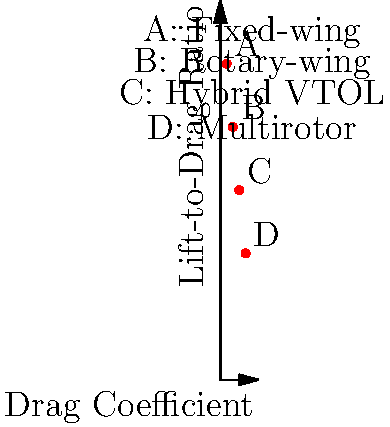Based on the aerodynamic performance chart of different military drone designs, which type of drone is likely to have the best range and endurance for long-duration surveillance missions? To determine which drone design is best suited for long-duration surveillance missions, we need to analyze the aerodynamic performance chart:

1. The x-axis represents the drag coefficient, where a lower value indicates less air resistance.
2. The y-axis shows the lift-to-drag ratio, where a higher value indicates better aerodynamic efficiency.

Let's examine each drone type:

A (Fixed-wing): 
- Lowest drag coefficient (≈0.2)
- Highest lift-to-drag ratio (≈10)

B (Rotary-wing):
- Second-lowest drag coefficient (≈0.4)
- Second-highest lift-to-drag ratio (≈8)

C (Hybrid VTOL):
- Second-highest drag coefficient (≈0.6)
- Third-highest lift-to-drag ratio (≈6)

D (Multirotor):
- Highest drag coefficient (≈0.8)
- Lowest lift-to-drag ratio (≈4)

For long-duration surveillance missions, we want a drone with:
1. Low drag coefficient: This reduces energy consumption, allowing for longer flight times.
2. High lift-to-drag ratio: This indicates better gliding ability and overall aerodynamic efficiency.

The fixed-wing design (A) excels in both these aspects, having the lowest drag coefficient and the highest lift-to-drag ratio. This combination allows it to:
- Consume less energy during flight
- Glide more efficiently
- Maintain altitude with minimal power input

These characteristics translate to longer range and endurance, making the fixed-wing design ideal for long-duration surveillance missions.
Answer: Fixed-wing drone (A) 